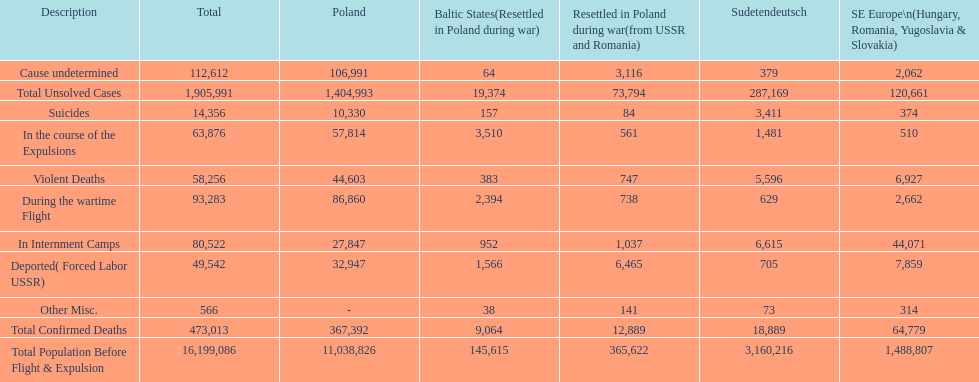What is the total of deaths in internment camps and during the wartime flight? 173,805. 